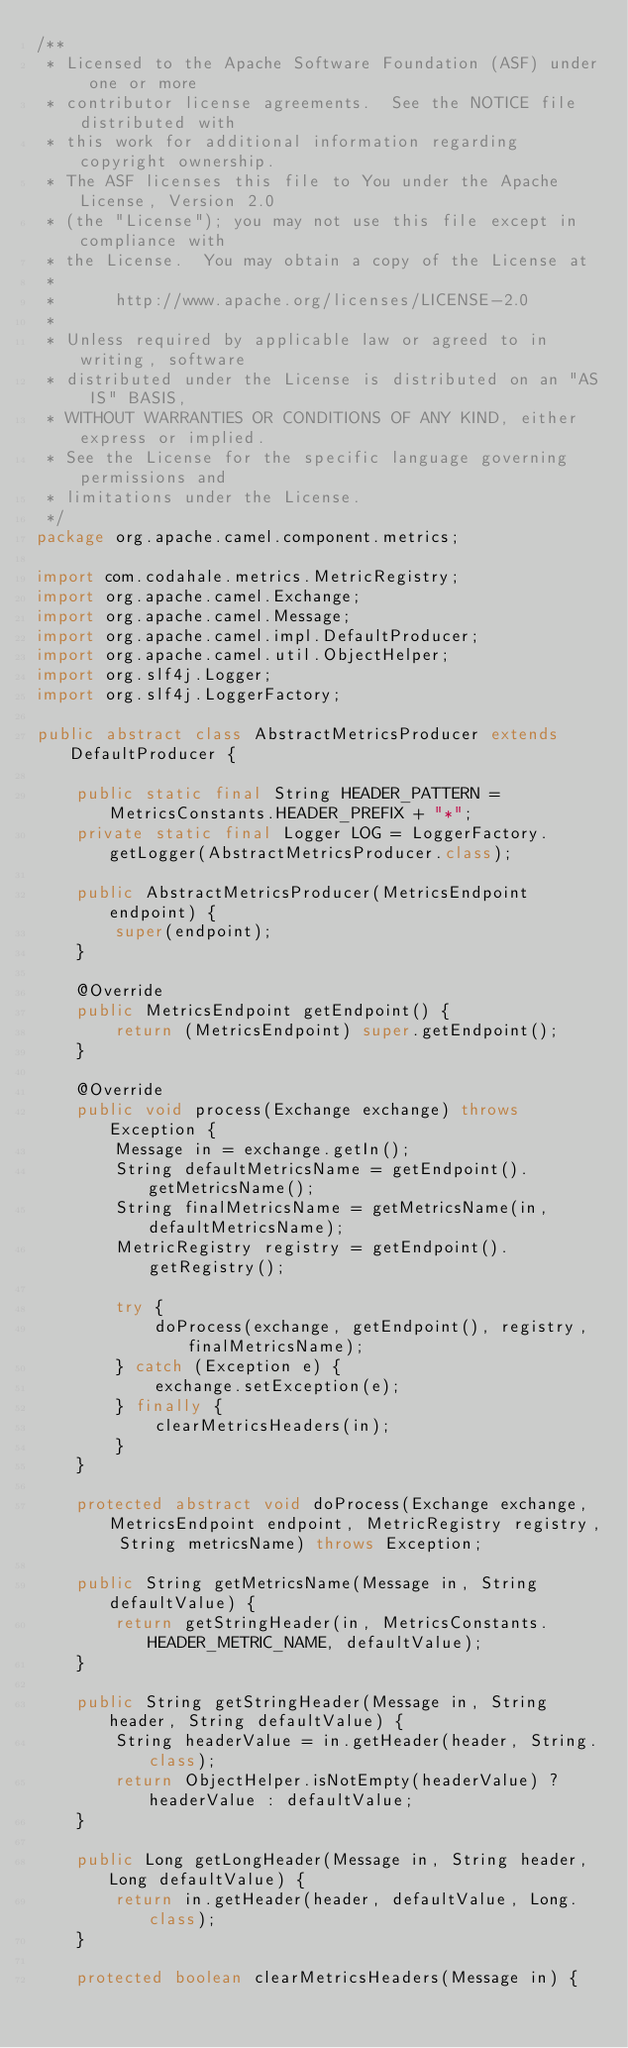Convert code to text. <code><loc_0><loc_0><loc_500><loc_500><_Java_>/**
 * Licensed to the Apache Software Foundation (ASF) under one or more
 * contributor license agreements.  See the NOTICE file distributed with
 * this work for additional information regarding copyright ownership.
 * The ASF licenses this file to You under the Apache License, Version 2.0
 * (the "License"); you may not use this file except in compliance with
 * the License.  You may obtain a copy of the License at
 *
 *      http://www.apache.org/licenses/LICENSE-2.0
 *
 * Unless required by applicable law or agreed to in writing, software
 * distributed under the License is distributed on an "AS IS" BASIS,
 * WITHOUT WARRANTIES OR CONDITIONS OF ANY KIND, either express or implied.
 * See the License for the specific language governing permissions and
 * limitations under the License.
 */
package org.apache.camel.component.metrics;

import com.codahale.metrics.MetricRegistry;
import org.apache.camel.Exchange;
import org.apache.camel.Message;
import org.apache.camel.impl.DefaultProducer;
import org.apache.camel.util.ObjectHelper;
import org.slf4j.Logger;
import org.slf4j.LoggerFactory;

public abstract class AbstractMetricsProducer extends DefaultProducer {

    public static final String HEADER_PATTERN = MetricsConstants.HEADER_PREFIX + "*";
    private static final Logger LOG = LoggerFactory.getLogger(AbstractMetricsProducer.class);

    public AbstractMetricsProducer(MetricsEndpoint endpoint) {
        super(endpoint);
    }

    @Override
    public MetricsEndpoint getEndpoint() {
        return (MetricsEndpoint) super.getEndpoint();
    }

    @Override
    public void process(Exchange exchange) throws Exception {
        Message in = exchange.getIn();
        String defaultMetricsName = getEndpoint().getMetricsName();
        String finalMetricsName = getMetricsName(in, defaultMetricsName);
        MetricRegistry registry = getEndpoint().getRegistry();

        try {
            doProcess(exchange, getEndpoint(), registry, finalMetricsName);
        } catch (Exception e) {
            exchange.setException(e);
        } finally {
            clearMetricsHeaders(in);
        }
    }

    protected abstract void doProcess(Exchange exchange, MetricsEndpoint endpoint, MetricRegistry registry, String metricsName) throws Exception;

    public String getMetricsName(Message in, String defaultValue) {
        return getStringHeader(in, MetricsConstants.HEADER_METRIC_NAME, defaultValue);
    }

    public String getStringHeader(Message in, String header, String defaultValue) {
        String headerValue = in.getHeader(header, String.class);
        return ObjectHelper.isNotEmpty(headerValue) ? headerValue : defaultValue;
    }

    public Long getLongHeader(Message in, String header, Long defaultValue) {
        return in.getHeader(header, defaultValue, Long.class);
    }

    protected boolean clearMetricsHeaders(Message in) {</code> 